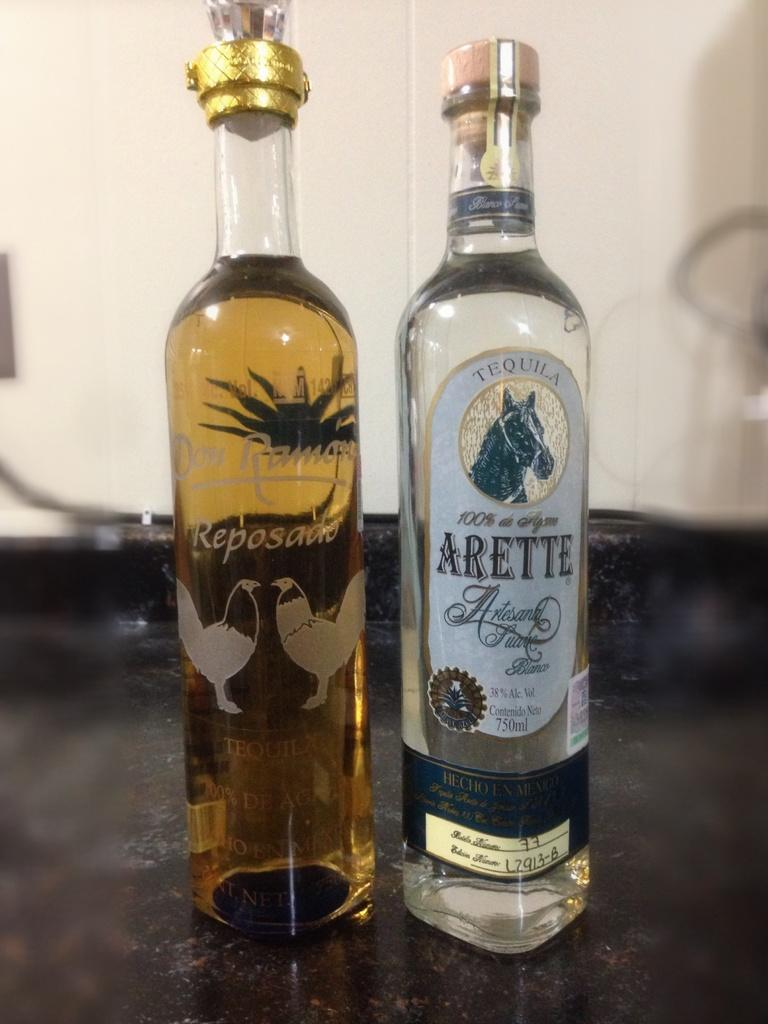<image>
Relay a brief, clear account of the picture shown. A bottle of 38% tequila has a picture of a horse on the label. 